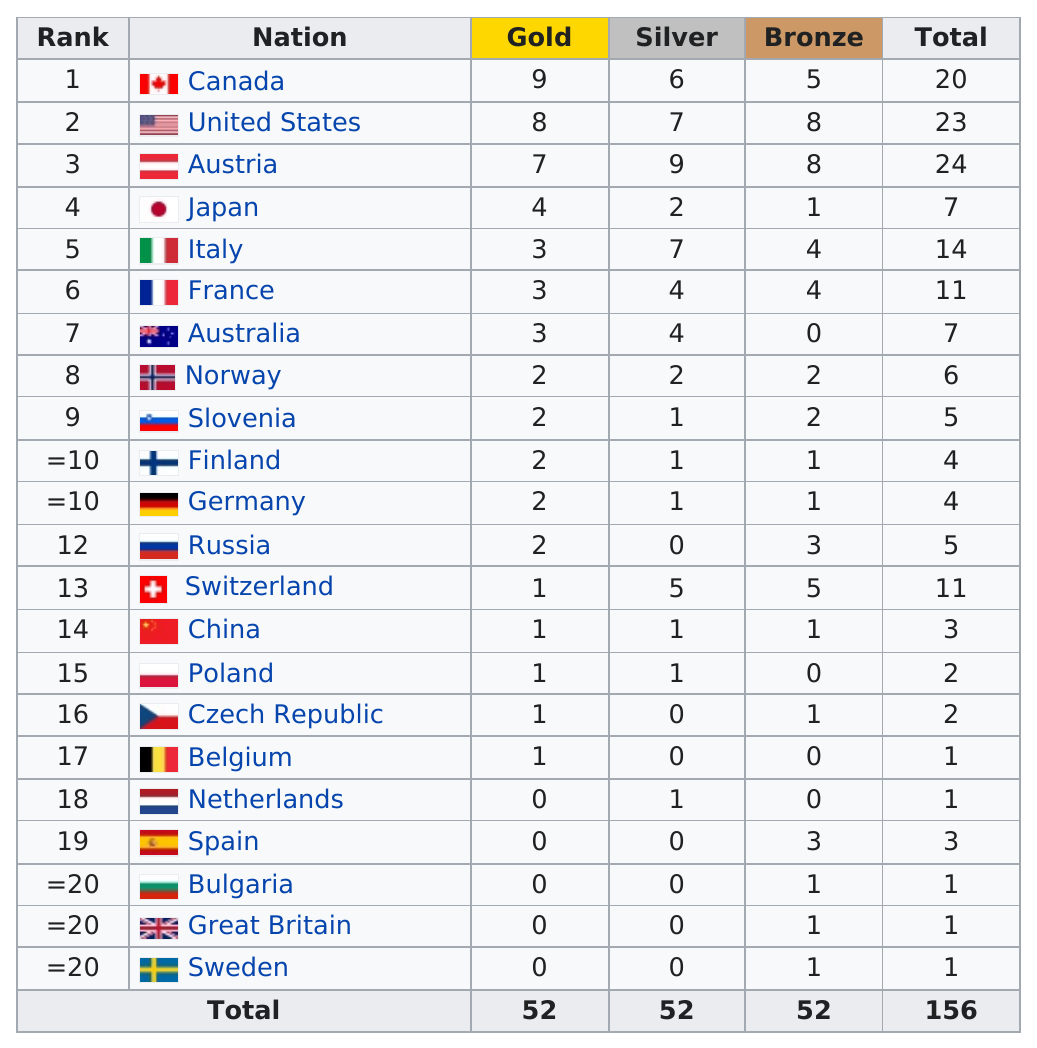Point out several critical features in this image. Japan finished after Austria in rank. The next country to have the most gold medals after the United States was Austria. In the 2013 snowboard world cup, a total of 156 medals were awarded. The United States and Austria are the countries that have won at least six bronze medals. Canada was ranked first in the total number of gold medals in the nation. 